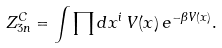Convert formula to latex. <formula><loc_0><loc_0><loc_500><loc_500>Z _ { 3 n } ^ { C } = \int \prod d x ^ { i } \, V ( x ) \, e ^ { - \beta V ( x ) } .</formula> 